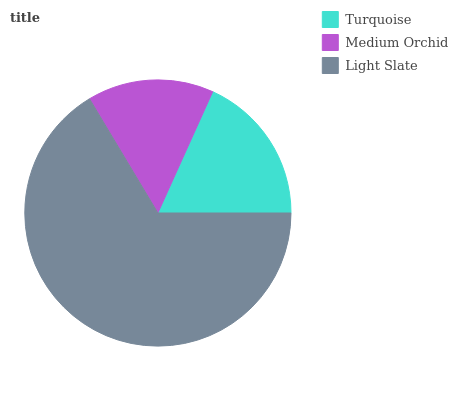Is Medium Orchid the minimum?
Answer yes or no. Yes. Is Light Slate the maximum?
Answer yes or no. Yes. Is Light Slate the minimum?
Answer yes or no. No. Is Medium Orchid the maximum?
Answer yes or no. No. Is Light Slate greater than Medium Orchid?
Answer yes or no. Yes. Is Medium Orchid less than Light Slate?
Answer yes or no. Yes. Is Medium Orchid greater than Light Slate?
Answer yes or no. No. Is Light Slate less than Medium Orchid?
Answer yes or no. No. Is Turquoise the high median?
Answer yes or no. Yes. Is Turquoise the low median?
Answer yes or no. Yes. Is Medium Orchid the high median?
Answer yes or no. No. Is Medium Orchid the low median?
Answer yes or no. No. 